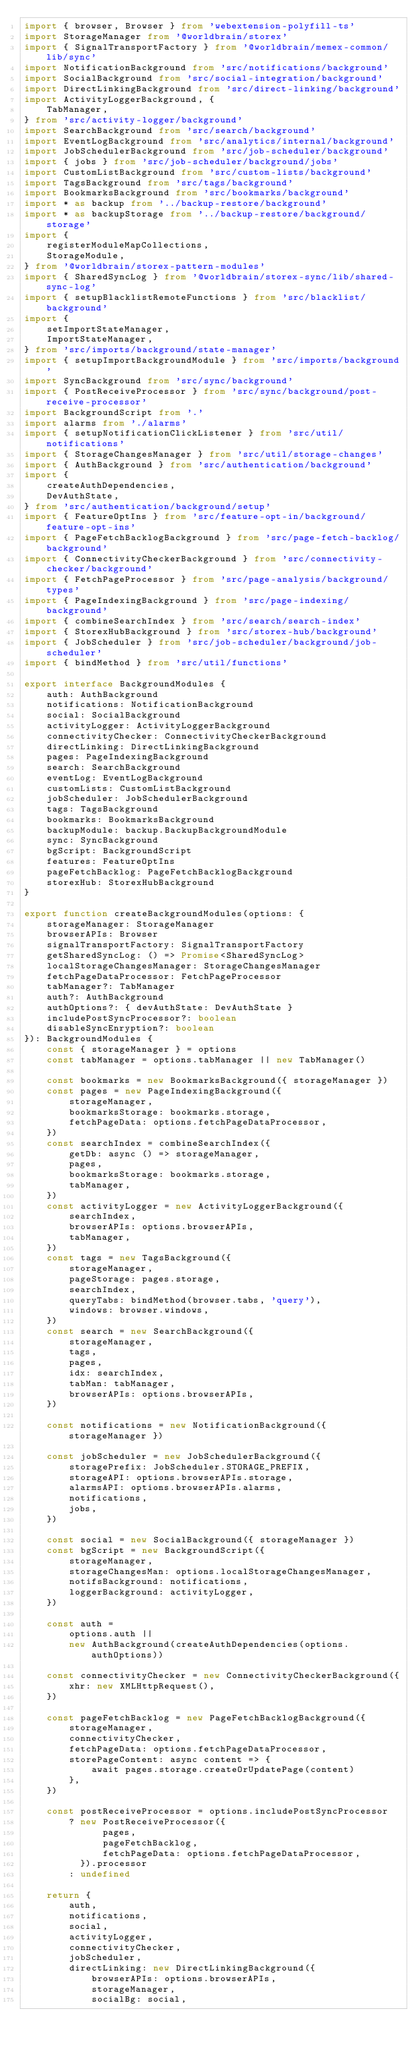Convert code to text. <code><loc_0><loc_0><loc_500><loc_500><_TypeScript_>import { browser, Browser } from 'webextension-polyfill-ts'
import StorageManager from '@worldbrain/storex'
import { SignalTransportFactory } from '@worldbrain/memex-common/lib/sync'
import NotificationBackground from 'src/notifications/background'
import SocialBackground from 'src/social-integration/background'
import DirectLinkingBackground from 'src/direct-linking/background'
import ActivityLoggerBackground, {
    TabManager,
} from 'src/activity-logger/background'
import SearchBackground from 'src/search/background'
import EventLogBackground from 'src/analytics/internal/background'
import JobSchedulerBackground from 'src/job-scheduler/background'
import { jobs } from 'src/job-scheduler/background/jobs'
import CustomListBackground from 'src/custom-lists/background'
import TagsBackground from 'src/tags/background'
import BookmarksBackground from 'src/bookmarks/background'
import * as backup from '../backup-restore/background'
import * as backupStorage from '../backup-restore/background/storage'
import {
    registerModuleMapCollections,
    StorageModule,
} from '@worldbrain/storex-pattern-modules'
import { SharedSyncLog } from '@worldbrain/storex-sync/lib/shared-sync-log'
import { setupBlacklistRemoteFunctions } from 'src/blacklist/background'
import {
    setImportStateManager,
    ImportStateManager,
} from 'src/imports/background/state-manager'
import { setupImportBackgroundModule } from 'src/imports/background'
import SyncBackground from 'src/sync/background'
import { PostReceiveProcessor } from 'src/sync/background/post-receive-processor'
import BackgroundScript from '.'
import alarms from './alarms'
import { setupNotificationClickListener } from 'src/util/notifications'
import { StorageChangesManager } from 'src/util/storage-changes'
import { AuthBackground } from 'src/authentication/background'
import {
    createAuthDependencies,
    DevAuthState,
} from 'src/authentication/background/setup'
import { FeatureOptIns } from 'src/feature-opt-in/background/feature-opt-ins'
import { PageFetchBacklogBackground } from 'src/page-fetch-backlog/background'
import { ConnectivityCheckerBackground } from 'src/connectivity-checker/background'
import { FetchPageProcessor } from 'src/page-analysis/background/types'
import { PageIndexingBackground } from 'src/page-indexing/background'
import { combineSearchIndex } from 'src/search/search-index'
import { StorexHubBackground } from 'src/storex-hub/background'
import { JobScheduler } from 'src/job-scheduler/background/job-scheduler'
import { bindMethod } from 'src/util/functions'

export interface BackgroundModules {
    auth: AuthBackground
    notifications: NotificationBackground
    social: SocialBackground
    activityLogger: ActivityLoggerBackground
    connectivityChecker: ConnectivityCheckerBackground
    directLinking: DirectLinkingBackground
    pages: PageIndexingBackground
    search: SearchBackground
    eventLog: EventLogBackground
    customLists: CustomListBackground
    jobScheduler: JobSchedulerBackground
    tags: TagsBackground
    bookmarks: BookmarksBackground
    backupModule: backup.BackupBackgroundModule
    sync: SyncBackground
    bgScript: BackgroundScript
    features: FeatureOptIns
    pageFetchBacklog: PageFetchBacklogBackground
    storexHub: StorexHubBackground
}

export function createBackgroundModules(options: {
    storageManager: StorageManager
    browserAPIs: Browser
    signalTransportFactory: SignalTransportFactory
    getSharedSyncLog: () => Promise<SharedSyncLog>
    localStorageChangesManager: StorageChangesManager
    fetchPageDataProcessor: FetchPageProcessor
    tabManager?: TabManager
    auth?: AuthBackground
    authOptions?: { devAuthState: DevAuthState }
    includePostSyncProcessor?: boolean
    disableSyncEnryption?: boolean
}): BackgroundModules {
    const { storageManager } = options
    const tabManager = options.tabManager || new TabManager()

    const bookmarks = new BookmarksBackground({ storageManager })
    const pages = new PageIndexingBackground({
        storageManager,
        bookmarksStorage: bookmarks.storage,
        fetchPageData: options.fetchPageDataProcessor,
    })
    const searchIndex = combineSearchIndex({
        getDb: async () => storageManager,
        pages,
        bookmarksStorage: bookmarks.storage,
        tabManager,
    })
    const activityLogger = new ActivityLoggerBackground({
        searchIndex,
        browserAPIs: options.browserAPIs,
        tabManager,
    })
    const tags = new TagsBackground({
        storageManager,
        pageStorage: pages.storage,
        searchIndex,
        queryTabs: bindMethod(browser.tabs, 'query'),
        windows: browser.windows,
    })
    const search = new SearchBackground({
        storageManager,
        tags,
        pages,
        idx: searchIndex,
        tabMan: tabManager,
        browserAPIs: options.browserAPIs,
    })

    const notifications = new NotificationBackground({ storageManager })

    const jobScheduler = new JobSchedulerBackground({
        storagePrefix: JobScheduler.STORAGE_PREFIX,
        storageAPI: options.browserAPIs.storage,
        alarmsAPI: options.browserAPIs.alarms,
        notifications,
        jobs,
    })

    const social = new SocialBackground({ storageManager })
    const bgScript = new BackgroundScript({
        storageManager,
        storageChangesMan: options.localStorageChangesManager,
        notifsBackground: notifications,
        loggerBackground: activityLogger,
    })

    const auth =
        options.auth ||
        new AuthBackground(createAuthDependencies(options.authOptions))

    const connectivityChecker = new ConnectivityCheckerBackground({
        xhr: new XMLHttpRequest(),
    })

    const pageFetchBacklog = new PageFetchBacklogBackground({
        storageManager,
        connectivityChecker,
        fetchPageData: options.fetchPageDataProcessor,
        storePageContent: async content => {
            await pages.storage.createOrUpdatePage(content)
        },
    })

    const postReceiveProcessor = options.includePostSyncProcessor
        ? new PostReceiveProcessor({
              pages,
              pageFetchBacklog,
              fetchPageData: options.fetchPageDataProcessor,
          }).processor
        : undefined

    return {
        auth,
        notifications,
        social,
        activityLogger,
        connectivityChecker,
        jobScheduler,
        directLinking: new DirectLinkingBackground({
            browserAPIs: options.browserAPIs,
            storageManager,
            socialBg: social,</code> 